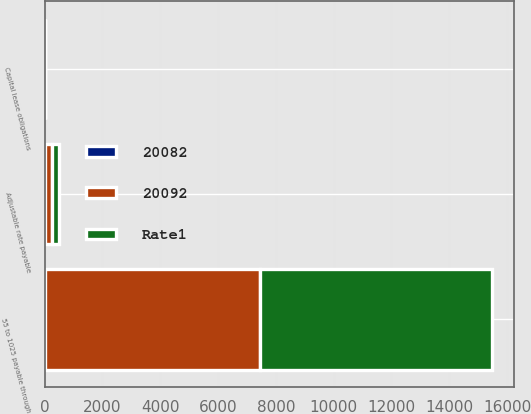Convert chart. <chart><loc_0><loc_0><loc_500><loc_500><stacked_bar_chart><ecel><fcel>Capital lease obligations<fcel>55 to 1025 payable through<fcel>Adjustable rate payable<nl><fcel>20082<fcel>9.5<fcel>7.7<fcel>1.2<nl><fcel>Rate1<fcel>3<fcel>8023<fcel>250<nl><fcel>20092<fcel>5<fcel>7446<fcel>250<nl></chart> 